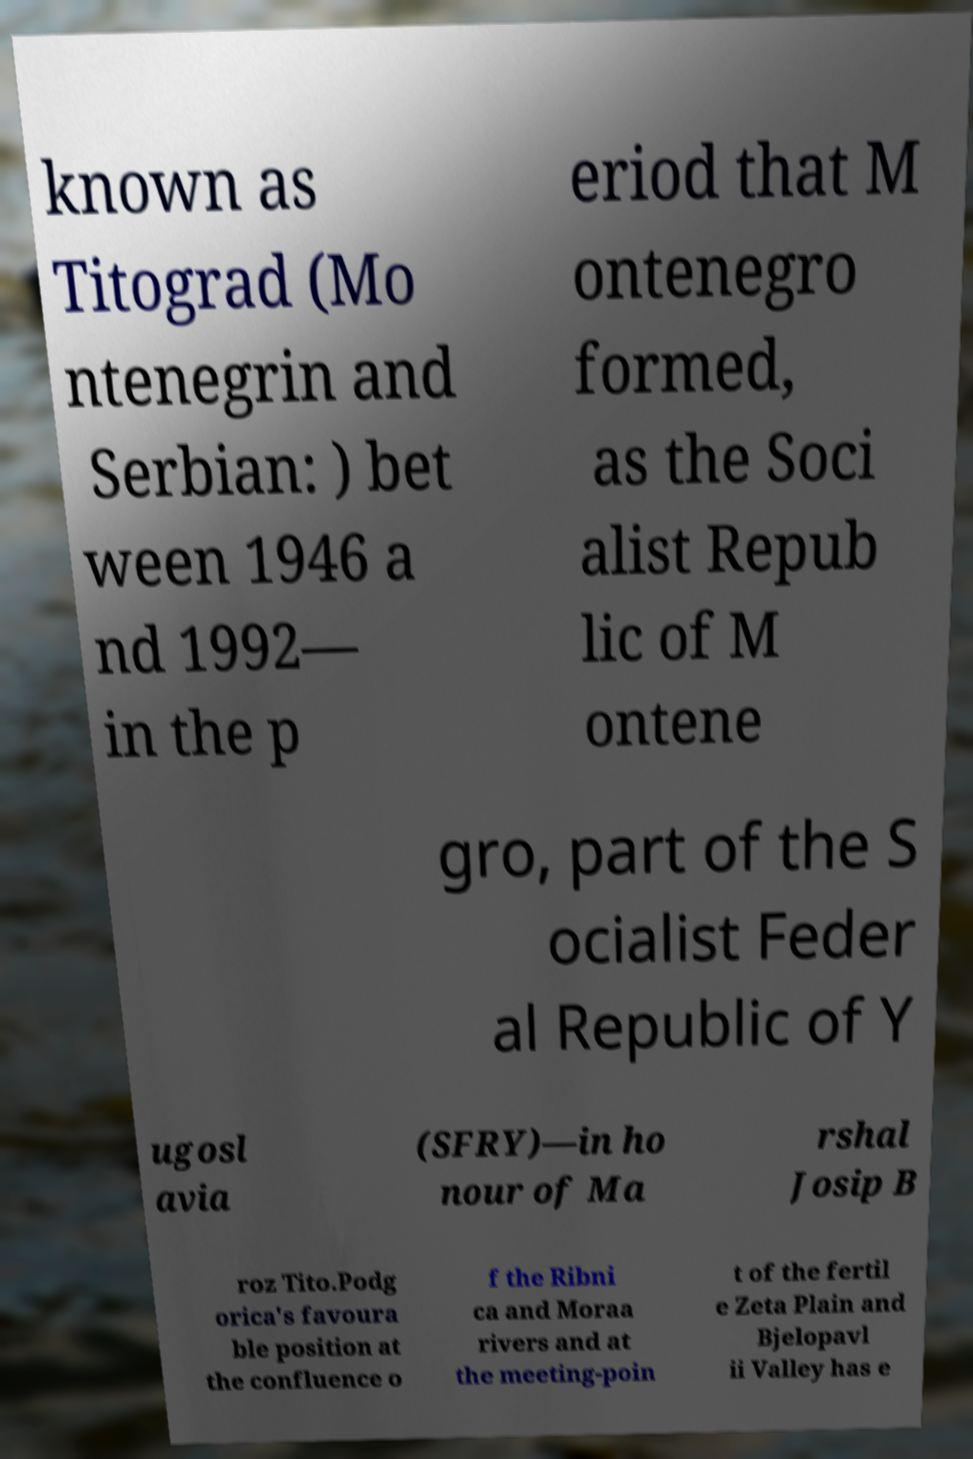There's text embedded in this image that I need extracted. Can you transcribe it verbatim? known as Titograd (Mo ntenegrin and Serbian: ) bet ween 1946 a nd 1992— in the p eriod that M ontenegro formed, as the Soci alist Repub lic of M ontene gro, part of the S ocialist Feder al Republic of Y ugosl avia (SFRY)—in ho nour of Ma rshal Josip B roz Tito.Podg orica's favoura ble position at the confluence o f the Ribni ca and Moraa rivers and at the meeting-poin t of the fertil e Zeta Plain and Bjelopavl ii Valley has e 